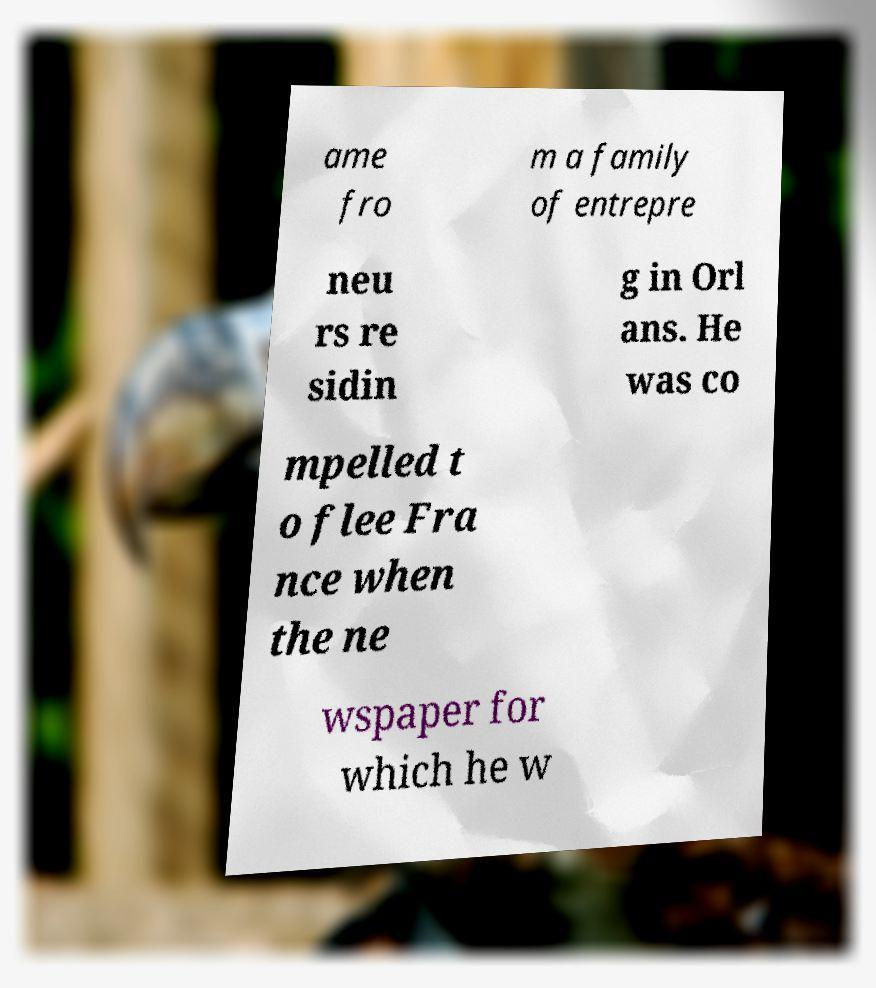What messages or text are displayed in this image? I need them in a readable, typed format. ame fro m a family of entrepre neu rs re sidin g in Orl ans. He was co mpelled t o flee Fra nce when the ne wspaper for which he w 